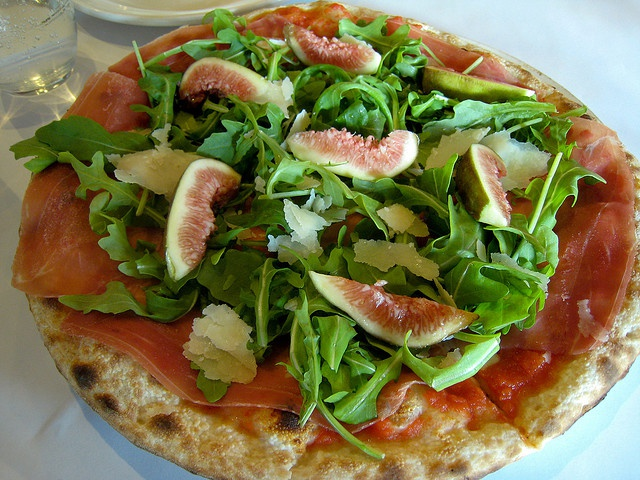Describe the objects in this image and their specific colors. I can see dining table in olive, black, tan, lightblue, and maroon tones, pizza in gray, olive, black, maroon, and brown tones, and cup in gray and darkgray tones in this image. 